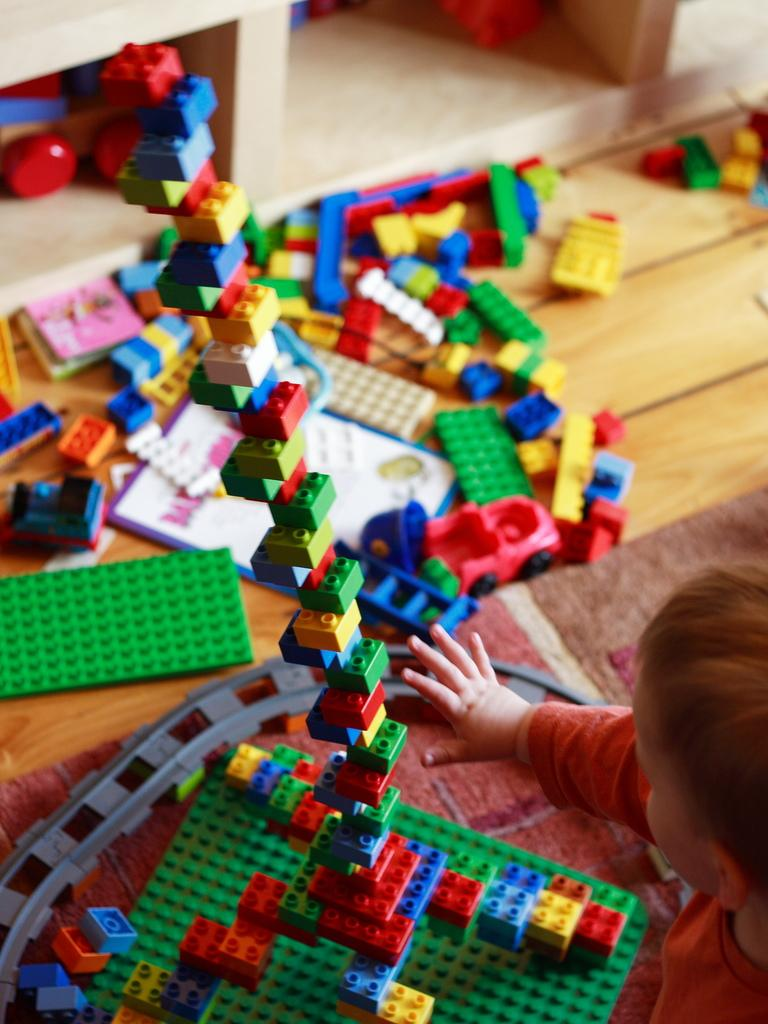What type of flooring is present in the image? The floor has a carpet. Who is present in the image? There is a kid in the image. What objects are in front of the kid? There are building blocks and toys in front of the kid. What else can be seen in the image? There is a card in the image. What is the boy doing with the sun in the image? There is no boy or sun present in the image. How does the grandmother interact with the toys in the image? There is no grandmother present in the image. 